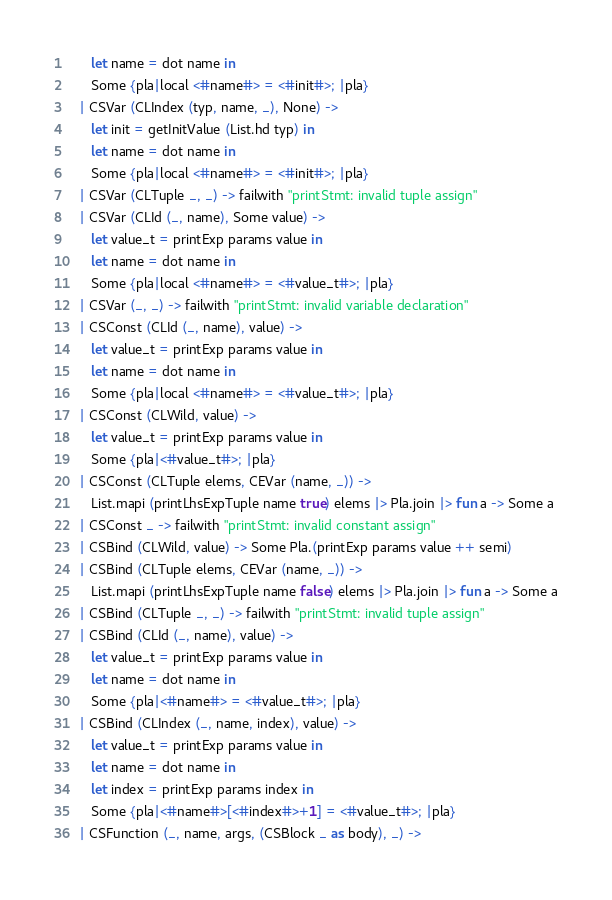Convert code to text. <code><loc_0><loc_0><loc_500><loc_500><_OCaml_>      let name = dot name in
      Some {pla|local <#name#> = <#init#>; |pla}
   | CSVar (CLIndex (typ, name, _), None) ->
      let init = getInitValue (List.hd typ) in
      let name = dot name in
      Some {pla|local <#name#> = <#init#>; |pla}
   | CSVar (CLTuple _, _) -> failwith "printStmt: invalid tuple assign"
   | CSVar (CLId (_, name), Some value) ->
      let value_t = printExp params value in
      let name = dot name in
      Some {pla|local <#name#> = <#value_t#>; |pla}
   | CSVar (_, _) -> failwith "printStmt: invalid variable declaration"
   | CSConst (CLId (_, name), value) ->
      let value_t = printExp params value in
      let name = dot name in
      Some {pla|local <#name#> = <#value_t#>; |pla}
   | CSConst (CLWild, value) ->
      let value_t = printExp params value in
      Some {pla|<#value_t#>; |pla}
   | CSConst (CLTuple elems, CEVar (name, _)) ->
      List.mapi (printLhsExpTuple name true) elems |> Pla.join |> fun a -> Some a
   | CSConst _ -> failwith "printStmt: invalid constant assign"
   | CSBind (CLWild, value) -> Some Pla.(printExp params value ++ semi)
   | CSBind (CLTuple elems, CEVar (name, _)) ->
      List.mapi (printLhsExpTuple name false) elems |> Pla.join |> fun a -> Some a
   | CSBind (CLTuple _, _) -> failwith "printStmt: invalid tuple assign"
   | CSBind (CLId (_, name), value) ->
      let value_t = printExp params value in
      let name = dot name in
      Some {pla|<#name#> = <#value_t#>; |pla}
   | CSBind (CLIndex (_, name, index), value) ->
      let value_t = printExp params value in
      let name = dot name in
      let index = printExp params index in
      Some {pla|<#name#>[<#index#>+1] = <#value_t#>; |pla}
   | CSFunction (_, name, args, (CSBlock _ as body), _) -></code> 